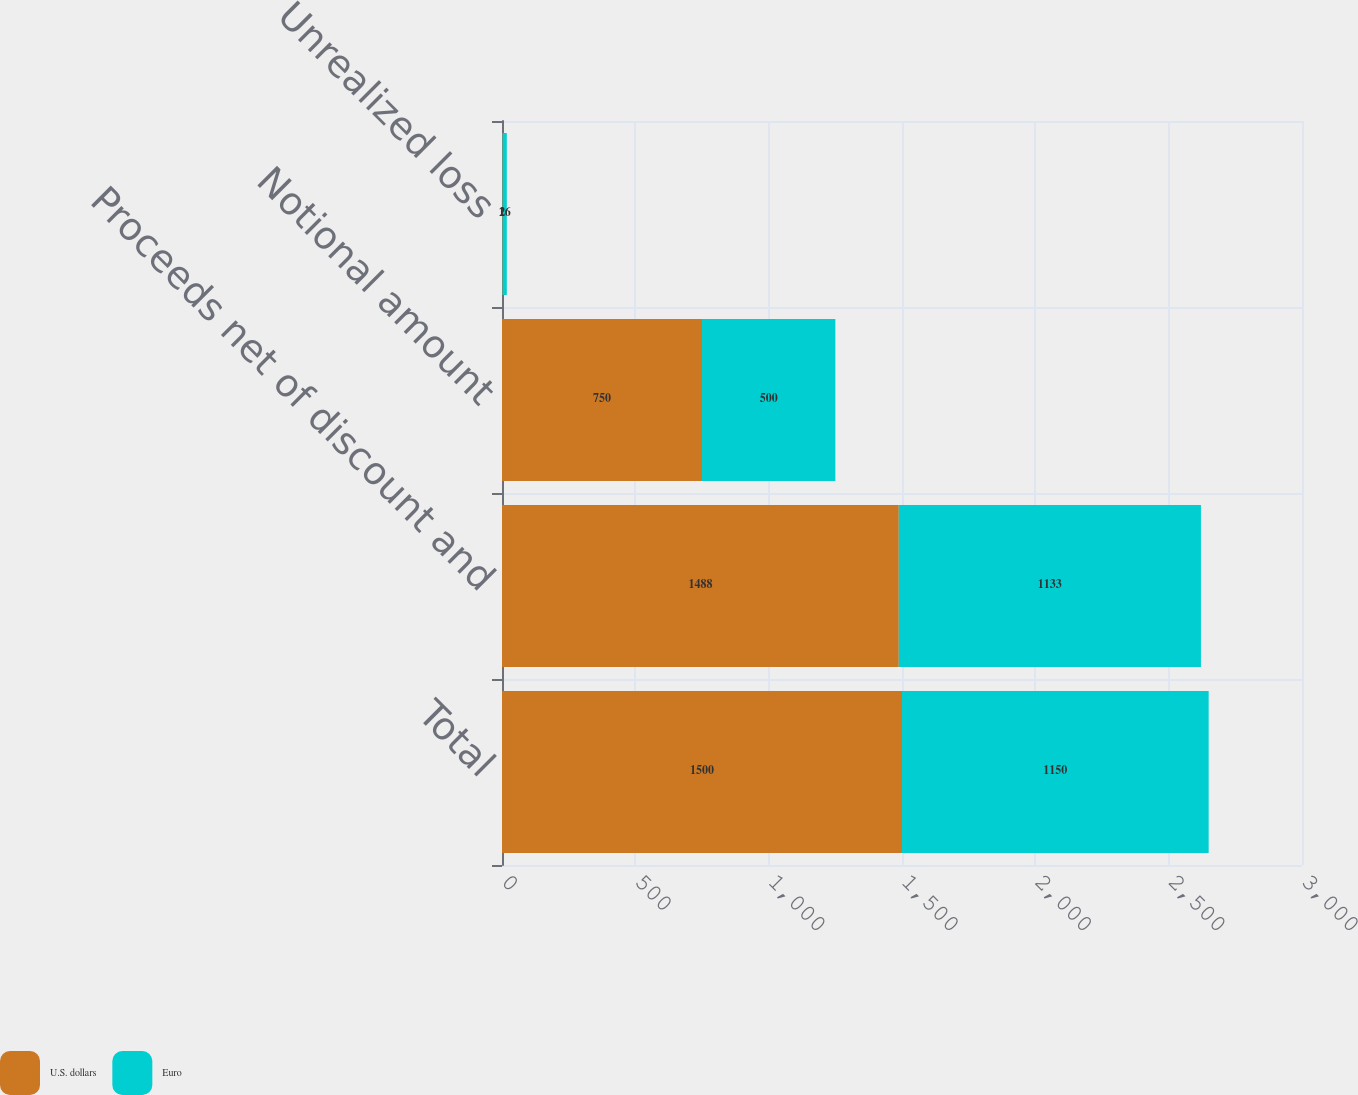Convert chart. <chart><loc_0><loc_0><loc_500><loc_500><stacked_bar_chart><ecel><fcel>Total<fcel>Proceeds net of discount and<fcel>Notional amount<fcel>Unrealized loss<nl><fcel>U.S. dollars<fcel>1500<fcel>1488<fcel>750<fcel>2<nl><fcel>Euro<fcel>1150<fcel>1133<fcel>500<fcel>16<nl></chart> 